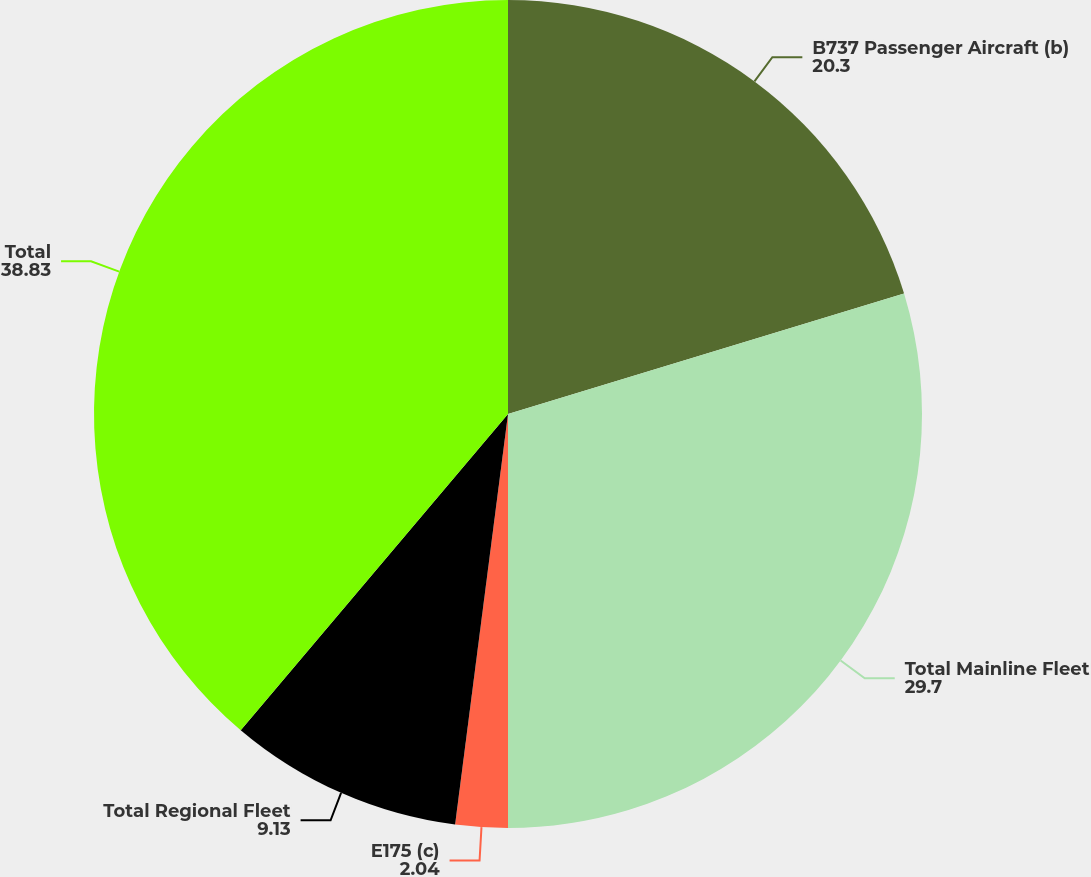<chart> <loc_0><loc_0><loc_500><loc_500><pie_chart><fcel>B737 Passenger Aircraft (b)<fcel>Total Mainline Fleet<fcel>E175 (c)<fcel>Total Regional Fleet<fcel>Total<nl><fcel>20.3%<fcel>29.7%<fcel>2.04%<fcel>9.13%<fcel>38.83%<nl></chart> 